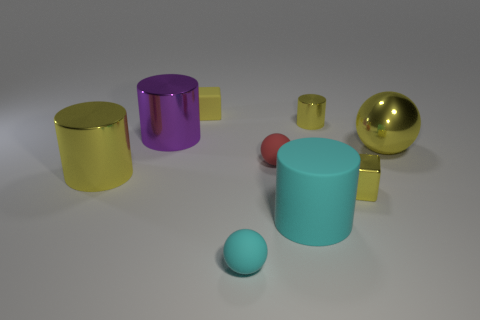Add 1 large spheres. How many objects exist? 10 Subtract all spheres. How many objects are left? 6 Add 7 red metallic cubes. How many red metallic cubes exist? 7 Subtract 0 purple spheres. How many objects are left? 9 Subtract all tiny cyan balls. Subtract all metal spheres. How many objects are left? 7 Add 4 big purple cylinders. How many big purple cylinders are left? 5 